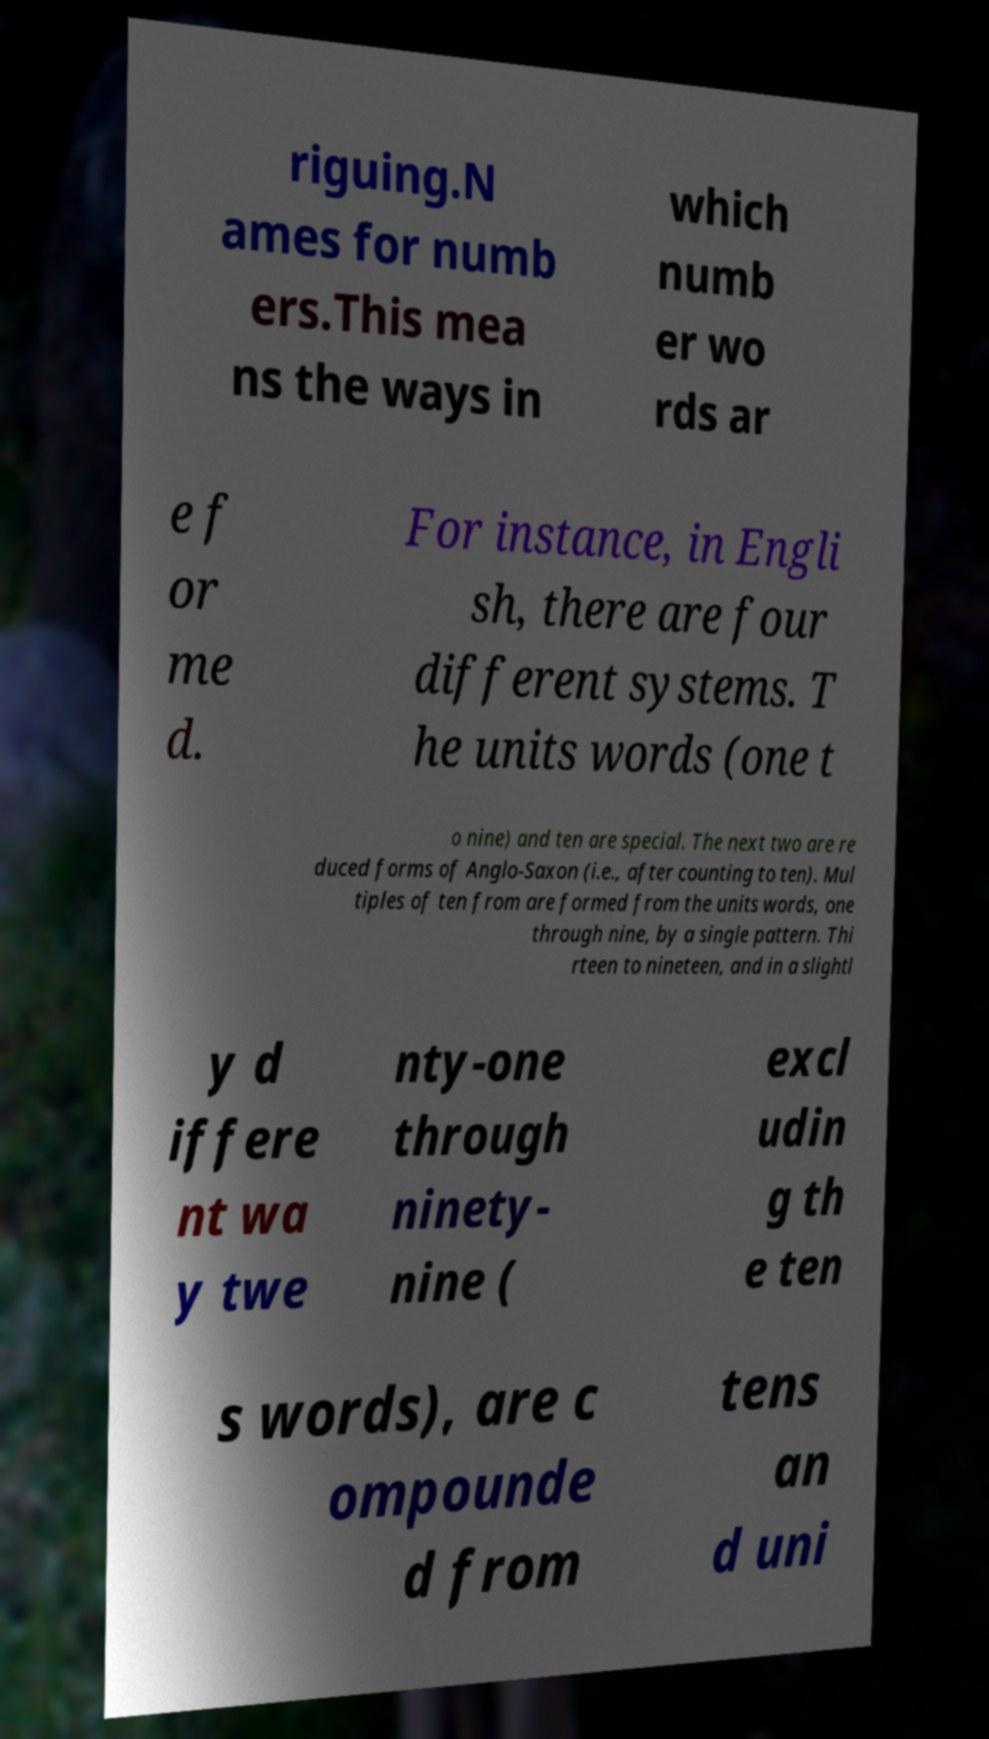I need the written content from this picture converted into text. Can you do that? riguing.N ames for numb ers.This mea ns the ways in which numb er wo rds ar e f or me d. For instance, in Engli sh, there are four different systems. T he units words (one t o nine) and ten are special. The next two are re duced forms of Anglo-Saxon (i.e., after counting to ten). Mul tiples of ten from are formed from the units words, one through nine, by a single pattern. Thi rteen to nineteen, and in a slightl y d iffere nt wa y twe nty-one through ninety- nine ( excl udin g th e ten s words), are c ompounde d from tens an d uni 